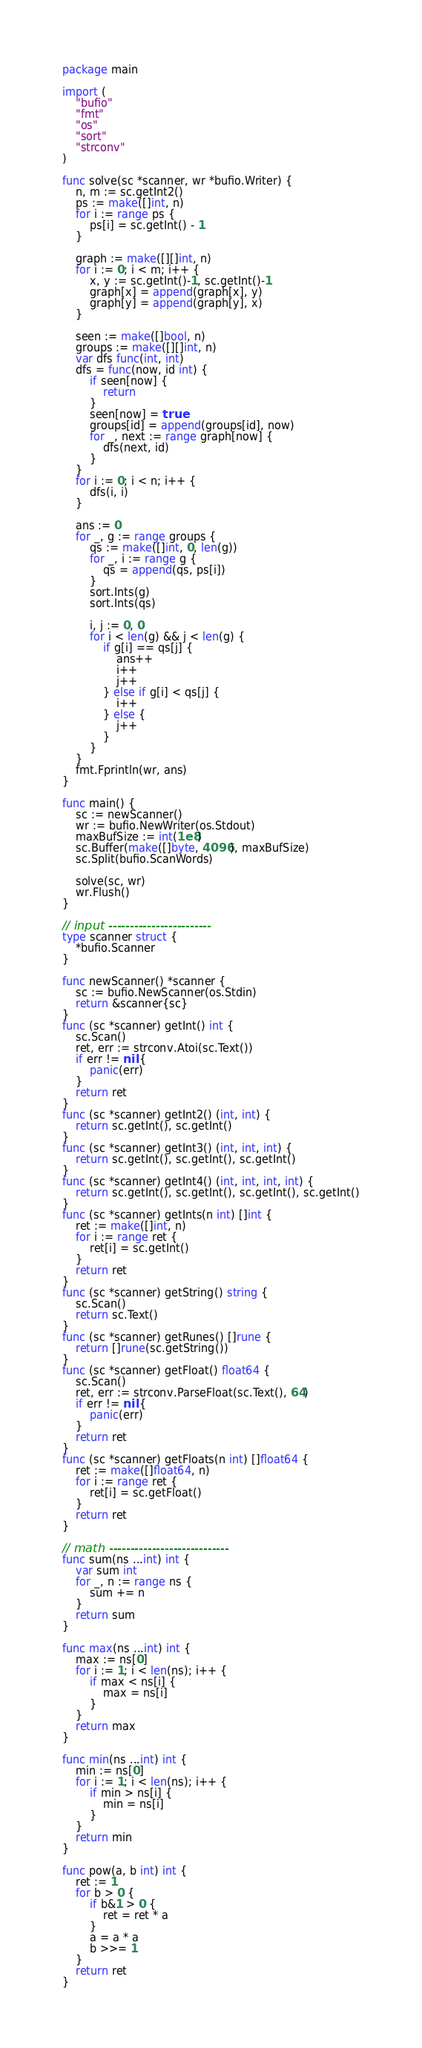<code> <loc_0><loc_0><loc_500><loc_500><_Go_>package main

import (
	"bufio"
	"fmt"
	"os"
	"sort"
	"strconv"
)

func solve(sc *scanner, wr *bufio.Writer) {
	n, m := sc.getInt2()
	ps := make([]int, n)
	for i := range ps {
		ps[i] = sc.getInt() - 1
	}

	graph := make([][]int, n)
	for i := 0; i < m; i++ {
		x, y := sc.getInt()-1, sc.getInt()-1
		graph[x] = append(graph[x], y)
		graph[y] = append(graph[y], x)
	}

	seen := make([]bool, n)
	groups := make([][]int, n)
	var dfs func(int, int)
	dfs = func(now, id int) {
		if seen[now] {
			return
		}
		seen[now] = true
		groups[id] = append(groups[id], now)
		for _, next := range graph[now] {
			dfs(next, id)
		}
	}
	for i := 0; i < n; i++ {
		dfs(i, i)
	}

	ans := 0
	for _, g := range groups {
		qs := make([]int, 0, len(g))
		for _, i := range g {
			qs = append(qs, ps[i])
		}
		sort.Ints(g)
		sort.Ints(qs)

		i, j := 0, 0
		for i < len(g) && j < len(g) {
			if g[i] == qs[j] {
				ans++
				i++
				j++
			} else if g[i] < qs[j] {
				i++
			} else {
				j++
			}
		}
	}
	fmt.Fprintln(wr, ans)
}

func main() {
	sc := newScanner()
	wr := bufio.NewWriter(os.Stdout)
	maxBufSize := int(1e8)
	sc.Buffer(make([]byte, 4096), maxBufSize)
	sc.Split(bufio.ScanWords)

	solve(sc, wr)
	wr.Flush()
}

// input ------------------------
type scanner struct {
	*bufio.Scanner
}

func newScanner() *scanner {
	sc := bufio.NewScanner(os.Stdin)
	return &scanner{sc}
}
func (sc *scanner) getInt() int {
	sc.Scan()
	ret, err := strconv.Atoi(sc.Text())
	if err != nil {
		panic(err)
	}
	return ret
}
func (sc *scanner) getInt2() (int, int) {
	return sc.getInt(), sc.getInt()
}
func (sc *scanner) getInt3() (int, int, int) {
	return sc.getInt(), sc.getInt(), sc.getInt()
}
func (sc *scanner) getInt4() (int, int, int, int) {
	return sc.getInt(), sc.getInt(), sc.getInt(), sc.getInt()
}
func (sc *scanner) getInts(n int) []int {
	ret := make([]int, n)
	for i := range ret {
		ret[i] = sc.getInt()
	}
	return ret
}
func (sc *scanner) getString() string {
	sc.Scan()
	return sc.Text()
}
func (sc *scanner) getRunes() []rune {
	return []rune(sc.getString())
}
func (sc *scanner) getFloat() float64 {
	sc.Scan()
	ret, err := strconv.ParseFloat(sc.Text(), 64)
	if err != nil {
		panic(err)
	}
	return ret
}
func (sc *scanner) getFloats(n int) []float64 {
	ret := make([]float64, n)
	for i := range ret {
		ret[i] = sc.getFloat()
	}
	return ret
}

// math ----------------------------
func sum(ns ...int) int {
	var sum int
	for _, n := range ns {
		sum += n
	}
	return sum
}

func max(ns ...int) int {
	max := ns[0]
	for i := 1; i < len(ns); i++ {
		if max < ns[i] {
			max = ns[i]
		}
	}
	return max
}

func min(ns ...int) int {
	min := ns[0]
	for i := 1; i < len(ns); i++ {
		if min > ns[i] {
			min = ns[i]
		}
	}
	return min
}

func pow(a, b int) int {
	ret := 1
	for b > 0 {
		if b&1 > 0 {
			ret = ret * a
		}
		a = a * a
		b >>= 1
	}
	return ret
}
</code> 